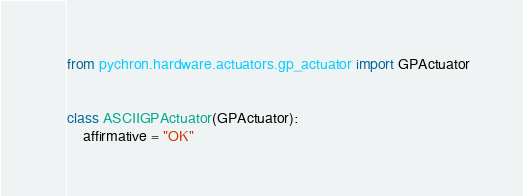Convert code to text. <code><loc_0><loc_0><loc_500><loc_500><_Python_>from pychron.hardware.actuators.gp_actuator import GPActuator


class ASCIIGPActuator(GPActuator):
    affirmative = "OK"</code> 